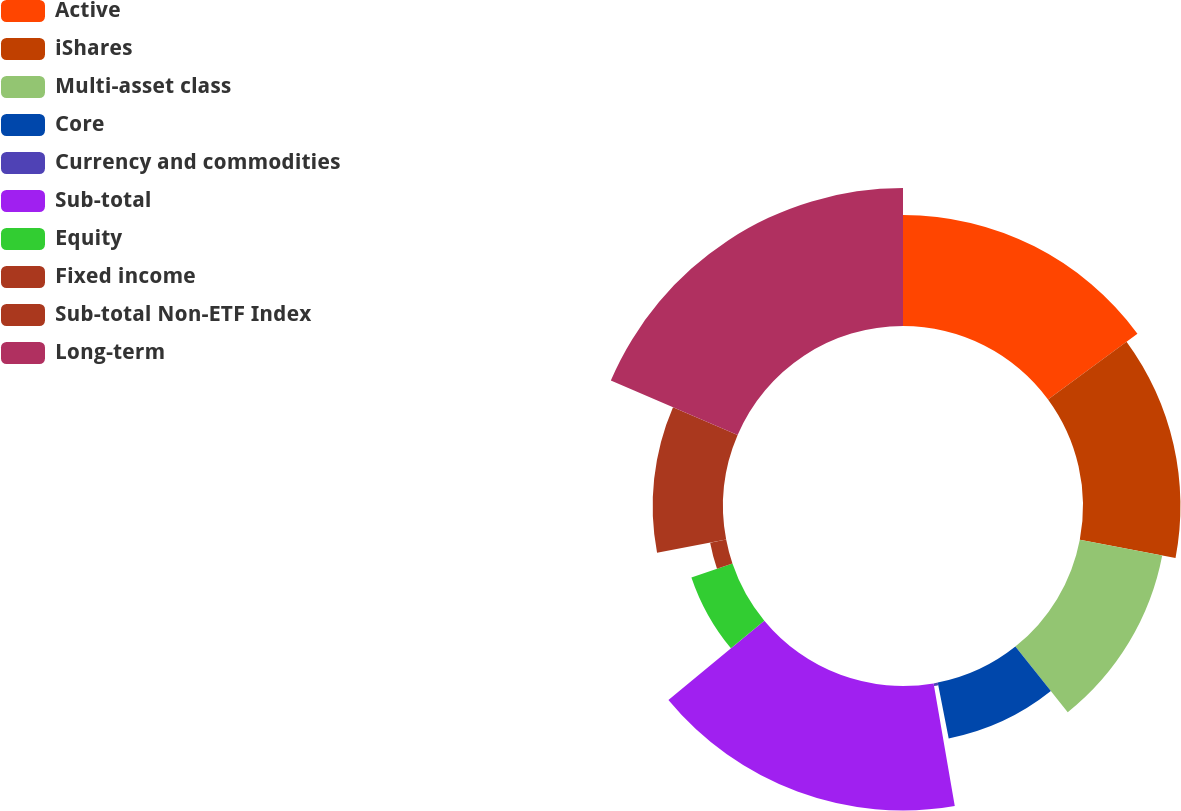Convert chart to OTSL. <chart><loc_0><loc_0><loc_500><loc_500><pie_chart><fcel>Active<fcel>iShares<fcel>Multi-asset class<fcel>Core<fcel>Currency and commodities<fcel>Sub-total<fcel>Equity<fcel>Fixed income<fcel>Sub-total Non-ETF Index<fcel>Long-term<nl><fcel>14.91%<fcel>13.09%<fcel>11.27%<fcel>7.64%<fcel>0.37%<fcel>16.72%<fcel>5.82%<fcel>2.19%<fcel>9.45%<fcel>18.54%<nl></chart> 